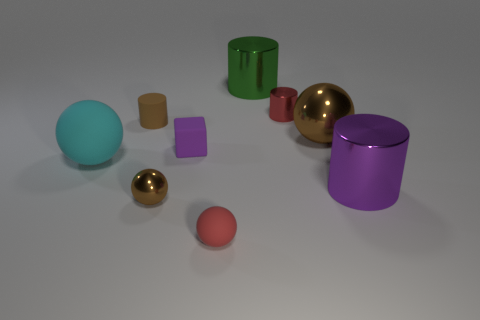There is a small rubber ball; is it the same color as the small metal thing that is behind the purple metallic object?
Make the answer very short. Yes. What material is the object that is the same color as the small cube?
Offer a terse response. Metal. Are there any tiny gray objects that have the same shape as the red shiny object?
Your answer should be compact. No. There is a big green cylinder; what number of tiny purple cubes are to the right of it?
Your response must be concise. 0. There is a tiny red object behind the cylinder in front of the big brown metallic thing; what is its material?
Ensure brevity in your answer.  Metal. There is a green cylinder that is the same size as the cyan rubber sphere; what material is it?
Make the answer very short. Metal. Are there any cylinders that have the same size as the cyan ball?
Make the answer very short. Yes. What color is the tiny metal object that is behind the tiny brown metal ball?
Make the answer very short. Red. There is a brown shiny ball right of the red metal thing; are there any tiny red objects that are to the right of it?
Provide a short and direct response. No. What number of other objects are there of the same color as the small matte cube?
Ensure brevity in your answer.  1. 